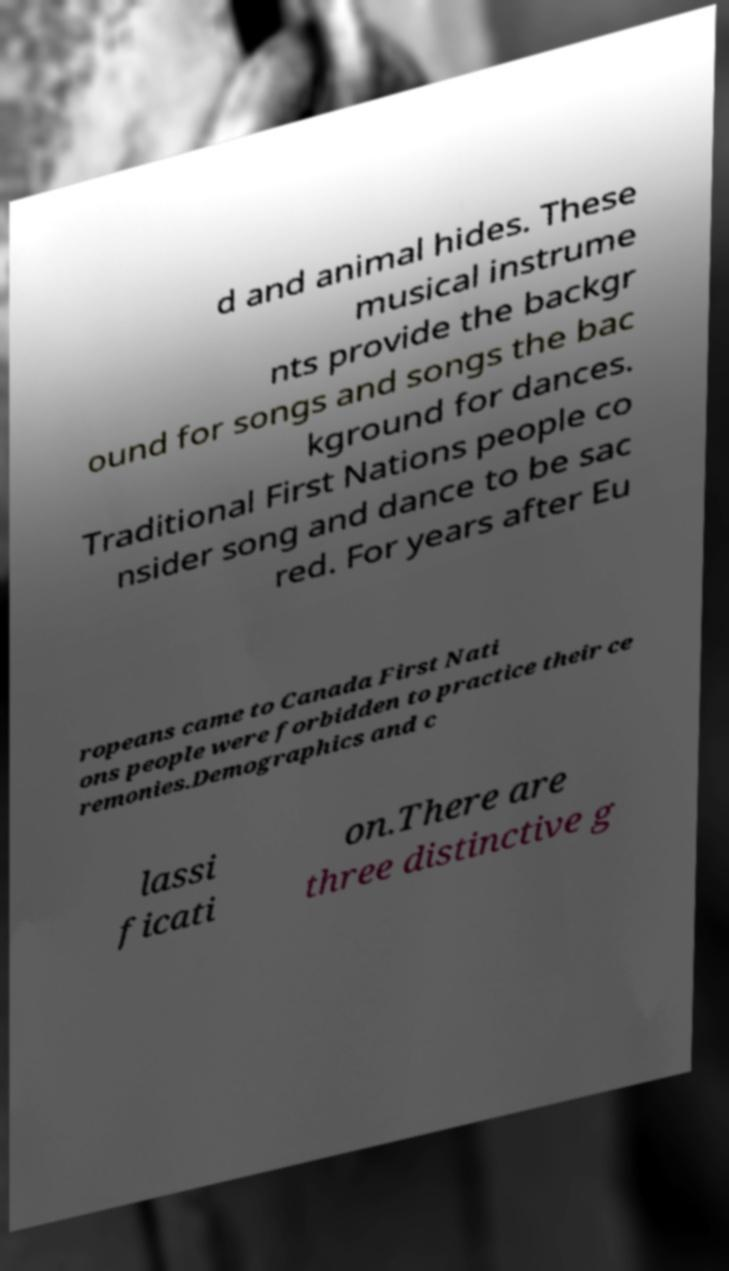What messages or text are displayed in this image? I need them in a readable, typed format. d and animal hides. These musical instrume nts provide the backgr ound for songs and songs the bac kground for dances. Traditional First Nations people co nsider song and dance to be sac red. For years after Eu ropeans came to Canada First Nati ons people were forbidden to practice their ce remonies.Demographics and c lassi ficati on.There are three distinctive g 